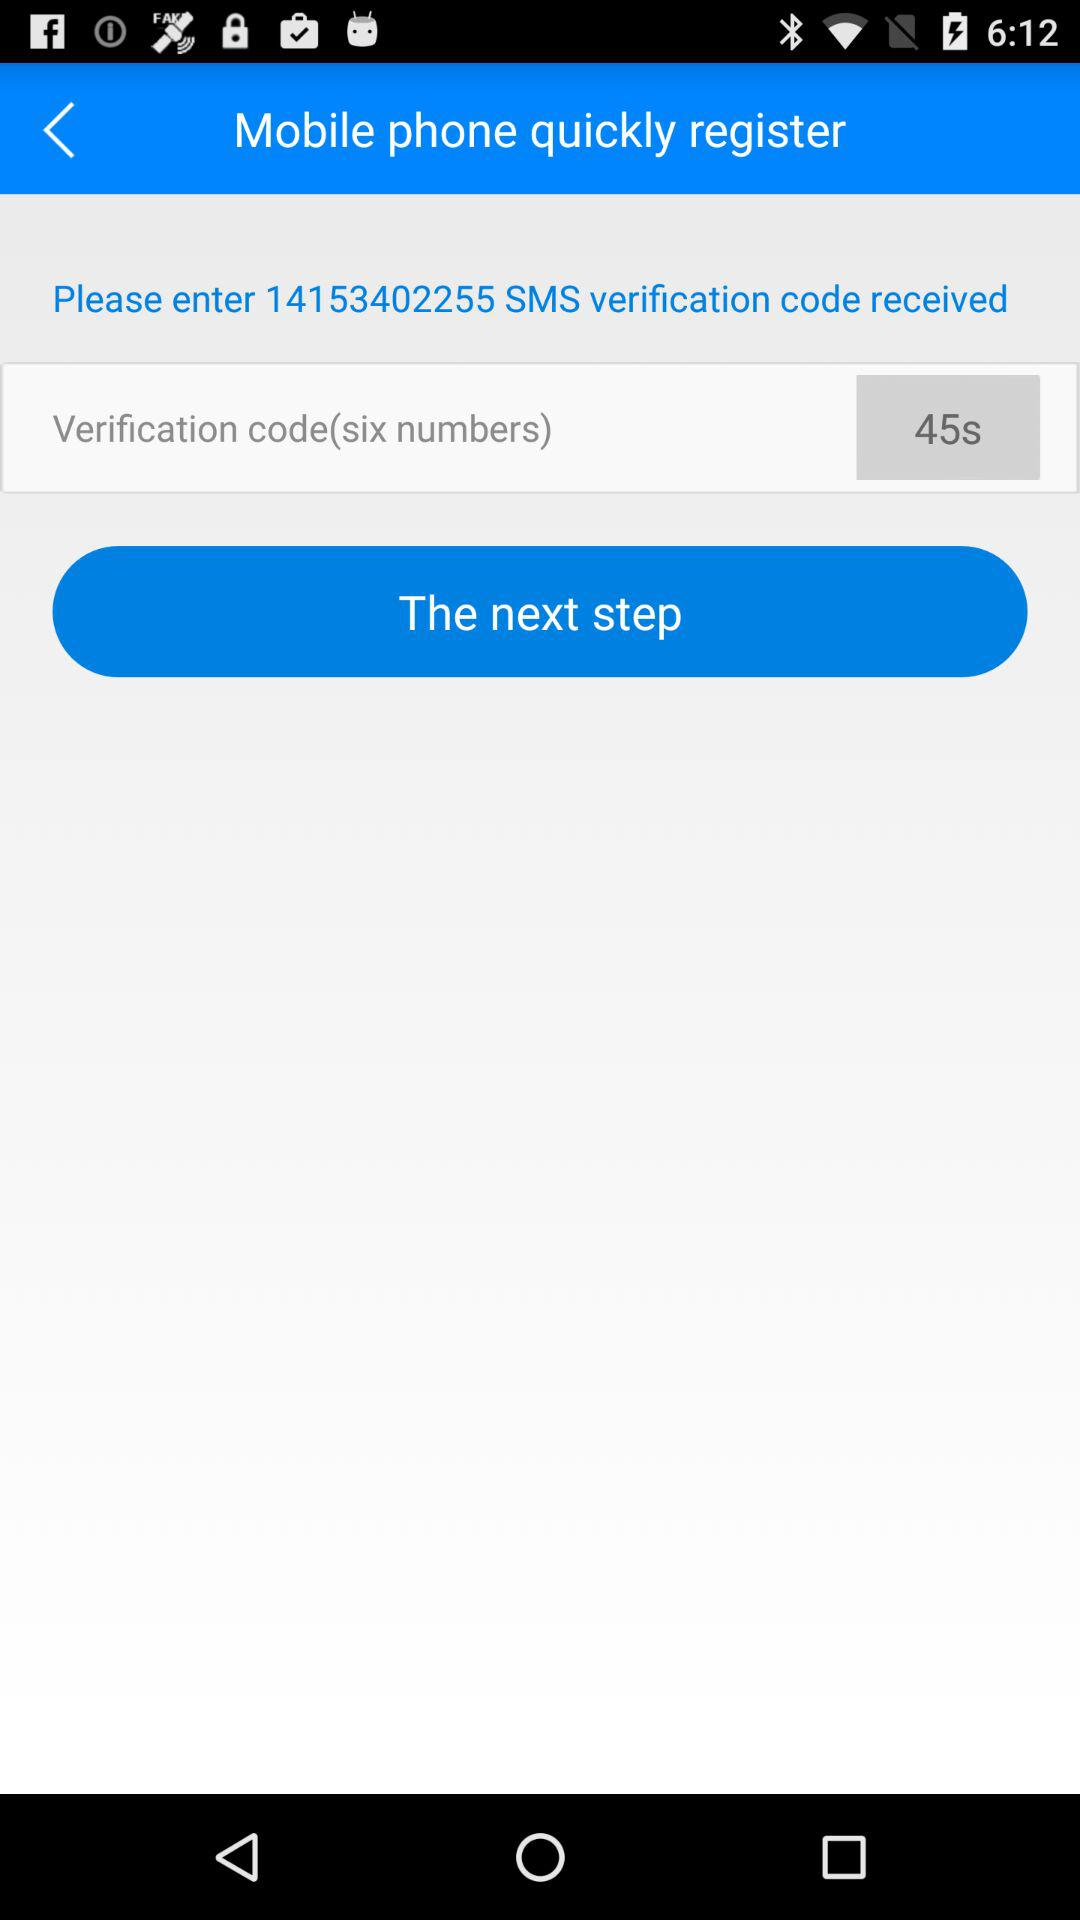How many seconds is the verification code valid for?
Answer the question using a single word or phrase. 45 